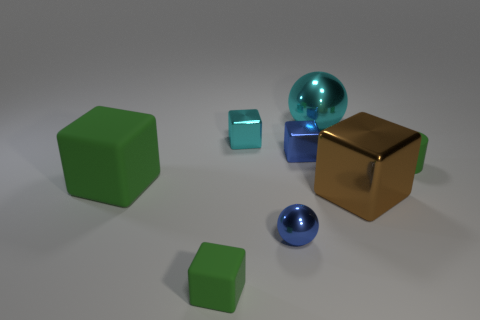Are the ball behind the green matte cylinder and the big green cube made of the same material?
Keep it short and to the point. No. What number of brown metal balls are the same size as the brown metal cube?
Provide a succinct answer. 0. Are there more tiny matte objects to the right of the small green rubber block than rubber cylinders in front of the big brown shiny thing?
Offer a very short reply. Yes. Are there any big cyan metal objects that have the same shape as the small cyan shiny thing?
Your answer should be very brief. No. There is a metallic block to the right of the small blue metal object behind the brown metal object; how big is it?
Your answer should be compact. Large. The blue metallic thing that is in front of the rubber thing to the left of the tiny rubber object on the left side of the green rubber cylinder is what shape?
Offer a terse response. Sphere. The other cyan sphere that is the same material as the small ball is what size?
Keep it short and to the point. Large. Is the number of big green matte things greater than the number of large yellow cylinders?
Offer a very short reply. Yes. What material is the green cube that is the same size as the brown thing?
Give a very brief answer. Rubber. There is a green cylinder that is in front of the cyan shiny block; is it the same size as the large brown shiny block?
Your response must be concise. No. 